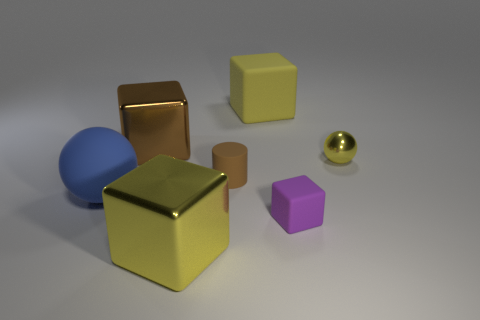There is a large yellow object that is in front of the tiny purple thing; what shape is it?
Ensure brevity in your answer.  Cube. There is a big metal block in front of the tiny yellow thing; is there a large object that is in front of it?
Keep it short and to the point. No. How many brown cubes are made of the same material as the brown cylinder?
Offer a very short reply. 0. There is a yellow object in front of the yellow shiny object that is behind the tiny thing that is on the left side of the large yellow rubber object; what size is it?
Provide a succinct answer. Large. There is a tiny metallic thing; how many small brown cylinders are on the right side of it?
Give a very brief answer. 0. Are there more brown rubber things than big yellow objects?
Keep it short and to the point. No. There is a sphere that is the same color as the large rubber block; what is its size?
Ensure brevity in your answer.  Small. What is the size of the cube that is both left of the small purple object and to the right of the big yellow metallic object?
Your answer should be very brief. Large. There is a yellow block that is behind the rubber block in front of the ball that is to the right of the big ball; what is it made of?
Ensure brevity in your answer.  Rubber. There is a small object that is the same color as the large matte block; what material is it?
Provide a succinct answer. Metal. 